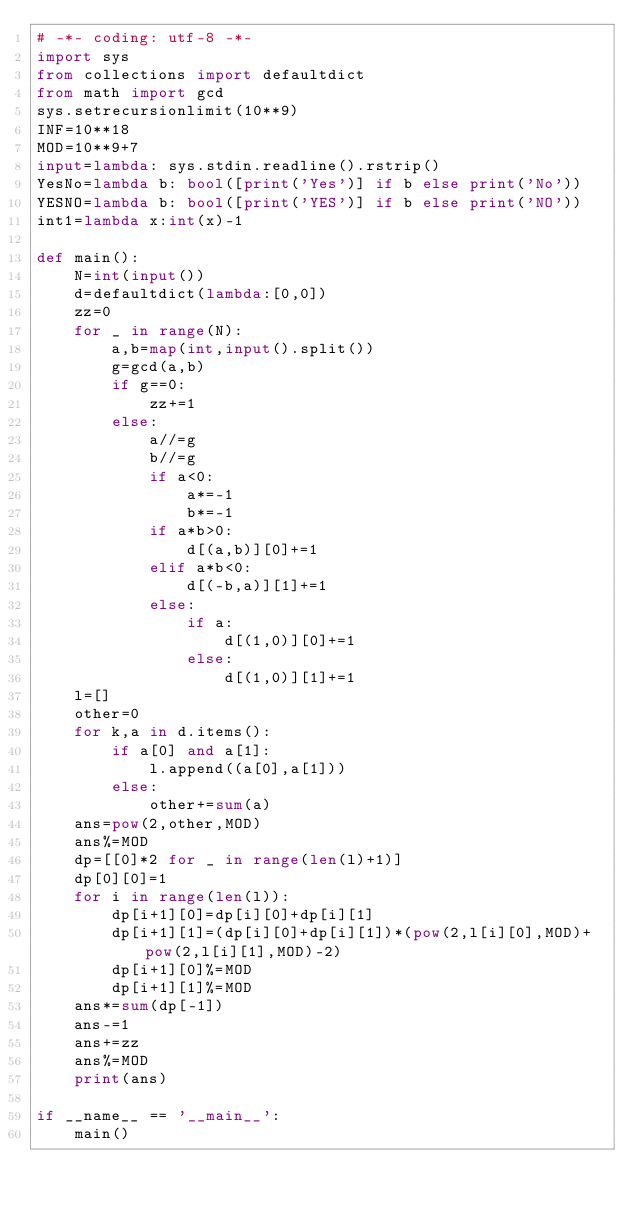<code> <loc_0><loc_0><loc_500><loc_500><_Python_># -*- coding: utf-8 -*-
import sys
from collections import defaultdict
from math import gcd
sys.setrecursionlimit(10**9)
INF=10**18
MOD=10**9+7
input=lambda: sys.stdin.readline().rstrip()
YesNo=lambda b: bool([print('Yes')] if b else print('No'))
YESNO=lambda b: bool([print('YES')] if b else print('NO'))
int1=lambda x:int(x)-1

def main():
    N=int(input())
    d=defaultdict(lambda:[0,0])
    zz=0
    for _ in range(N):
        a,b=map(int,input().split())
        g=gcd(a,b)
        if g==0:
            zz+=1
        else:
            a//=g
            b//=g
            if a<0:
                a*=-1
                b*=-1
            if a*b>0:
                d[(a,b)][0]+=1
            elif a*b<0:
                d[(-b,a)][1]+=1
            else:
                if a:
                    d[(1,0)][0]+=1
                else:
                    d[(1,0)][1]+=1
    l=[]
    other=0
    for k,a in d.items():
        if a[0] and a[1]:
            l.append((a[0],a[1]))
        else:
            other+=sum(a)
    ans=pow(2,other,MOD)
    ans%=MOD
    dp=[[0]*2 for _ in range(len(l)+1)]
    dp[0][0]=1
    for i in range(len(l)):
        dp[i+1][0]=dp[i][0]+dp[i][1]
        dp[i+1][1]=(dp[i][0]+dp[i][1])*(pow(2,l[i][0],MOD)+pow(2,l[i][1],MOD)-2)
        dp[i+1][0]%=MOD
        dp[i+1][1]%=MOD
    ans*=sum(dp[-1])
    ans-=1
    ans+=zz
    ans%=MOD
    print(ans)

if __name__ == '__main__':
    main()
</code> 